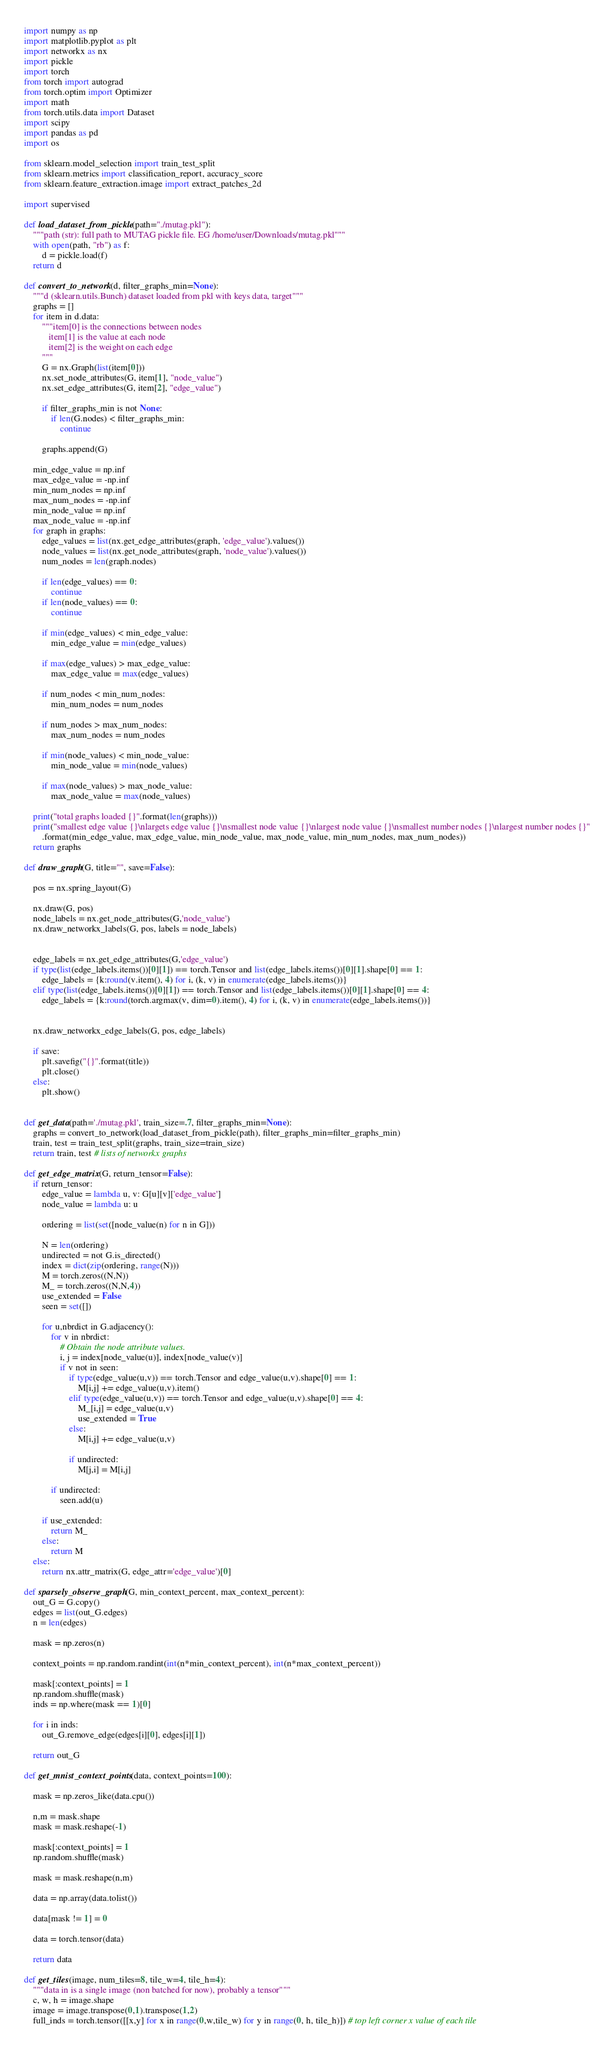<code> <loc_0><loc_0><loc_500><loc_500><_Python_>import numpy as np
import matplotlib.pyplot as plt
import networkx as nx
import pickle
import torch
from torch import autograd
from torch.optim import Optimizer
import math
from torch.utils.data import Dataset
import scipy
import pandas as pd
import os

from sklearn.model_selection import train_test_split
from sklearn.metrics import classification_report, accuracy_score
from sklearn.feature_extraction.image import extract_patches_2d

import supervised

def load_dataset_from_pickle(path="./mutag.pkl"):
    """path (str): full path to MUTAG pickle file. EG /home/user/Downloads/mutag.pkl"""
    with open(path, "rb") as f:
        d = pickle.load(f)
    return d

def convert_to_network(d, filter_graphs_min=None):
    """d (sklearn.utils.Bunch) dataset loaded from pkl with keys data, target"""
    graphs = []
    for item in d.data:
        """item[0] is the connections between nodes
           item[1] is the value at each node
           item[2] is the weight on each edge
        """
        G = nx.Graph(list(item[0]))
        nx.set_node_attributes(G, item[1], "node_value")
        nx.set_edge_attributes(G, item[2], "edge_value")

        if filter_graphs_min is not None:
            if len(G.nodes) < filter_graphs_min:
                continue

        graphs.append(G)

    min_edge_value = np.inf
    max_edge_value = -np.inf
    min_num_nodes = np.inf
    max_num_nodes = -np.inf
    min_node_value = np.inf 
    max_node_value = -np.inf
    for graph in graphs:
        edge_values = list(nx.get_edge_attributes(graph, 'edge_value').values())
        node_values = list(nx.get_node_attributes(graph, 'node_value').values())
        num_nodes = len(graph.nodes)

        if len(edge_values) == 0:
            continue
        if len(node_values) == 0:
            continue

        if min(edge_values) < min_edge_value:
            min_edge_value = min(edge_values)
        
        if max(edge_values) > max_edge_value:
            max_edge_value = max(edge_values)

        if num_nodes < min_num_nodes:
            min_num_nodes = num_nodes
        
        if num_nodes > max_num_nodes:
            max_num_nodes = num_nodes

        if min(node_values) < min_node_value:
            min_node_value = min(node_values)
        
        if max(node_values) > max_node_value:
            max_node_value = max(node_values)

    print("total graphs loaded {}".format(len(graphs)))
    print("smallest edge value {}\nlargets edge value {}\nsmallest node value {}\nlargest node value {}\nsmallest number nodes {}\nlargest number nodes {}"
        .format(min_edge_value, max_edge_value, min_node_value, max_node_value, min_num_nodes, max_num_nodes))
    return graphs

def draw_graph(G, title="", save=False):

    pos = nx.spring_layout(G)

    nx.draw(G, pos)
    node_labels = nx.get_node_attributes(G,'node_value')
    nx.draw_networkx_labels(G, pos, labels = node_labels)


    edge_labels = nx.get_edge_attributes(G,'edge_value')
    if type(list(edge_labels.items())[0][1]) == torch.Tensor and list(edge_labels.items())[0][1].shape[0] == 1:
        edge_labels = {k:round(v.item(), 4) for i, (k, v) in enumerate(edge_labels.items())}
    elif type(list(edge_labels.items())[0][1]) == torch.Tensor and list(edge_labels.items())[0][1].shape[0] == 4:
        edge_labels = {k:round(torch.argmax(v, dim=0).item(), 4) for i, (k, v) in enumerate(edge_labels.items())}

    
    nx.draw_networkx_edge_labels(G, pos, edge_labels)

    if save:
        plt.savefig("{}".format(title))
        plt.close()
    else:
        plt.show()
        

def get_data(path='./mutag.pkl', train_size=.7, filter_graphs_min=None):
    graphs = convert_to_network(load_dataset_from_pickle(path), filter_graphs_min=filter_graphs_min)
    train, test = train_test_split(graphs, train_size=train_size)
    return train, test # lists of networkx graphs

def get_edge_matrix(G, return_tensor=False):
    if return_tensor:
        edge_value = lambda u, v: G[u][v]['edge_value']
        node_value = lambda u: u

        ordering = list(set([node_value(n) for n in G]))

        N = len(ordering)
        undirected = not G.is_directed()   
        index = dict(zip(ordering, range(N)))
        M = torch.zeros((N,N))
        M_ = torch.zeros((N,N,4))
        use_extended = False
        seen = set([])

        for u,nbrdict in G.adjacency():
            for v in nbrdict:
                # Obtain the node attribute values.
                i, j = index[node_value(u)], index[node_value(v)]
                if v not in seen:
                    if type(edge_value(u,v)) == torch.Tensor and edge_value(u,v).shape[0] == 1:
                        M[i,j] += edge_value(u,v).item()
                    elif type(edge_value(u,v)) == torch.Tensor and edge_value(u,v).shape[0] == 4:
                        M_[i,j] = edge_value(u,v)
                        use_extended = True
                    else:
                        M[i,j] += edge_value(u,v)

                    if undirected:
                        M[j,i] = M[i,j]

            if undirected:
                seen.add(u)    

        if use_extended:
            return M_
        else:
            return M
    else:
        return nx.attr_matrix(G, edge_attr='edge_value')[0]

def sparsely_observe_graph(G, min_context_percent, max_context_percent):
    out_G = G.copy()
    edges = list(out_G.edges)
    n = len(edges)

    mask = np.zeros(n)
    
    context_points = np.random.randint(int(n*min_context_percent), int(n*max_context_percent))

    mask[:context_points] = 1
    np.random.shuffle(mask)
    inds = np.where(mask == 1)[0]

    for i in inds:
        out_G.remove_edge(edges[i][0], edges[i][1])

    return out_G

def get_mnist_context_points(data, context_points=100):
    
    mask = np.zeros_like(data.cpu())
    
    n,m = mask.shape
    mask = mask.reshape(-1)

    mask[:context_points] = 1
    np.random.shuffle(mask)

    mask = mask.reshape(n,m)
    
    data = np.array(data.tolist())

    data[mask != 1] = 0

    data = torch.tensor(data)
    
    return data

def get_tiles(image, num_tiles=8, tile_w=4, tile_h=4):
    """data in is a single image (non batched for now), probably a tensor"""
    c, w, h = image.shape
    image = image.transpose(0,1).transpose(1,2)
    full_inds = torch.tensor([[x,y] for x in range(0,w,tile_w) for y in range(0, h, tile_h)]) # top left corner x value of each tile
</code> 